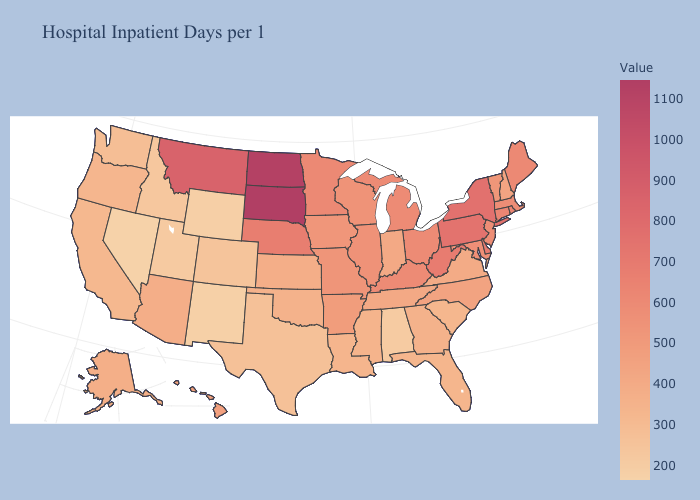Which states have the lowest value in the USA?
Be succinct. Nevada. Does Alabama have the highest value in the USA?
Quick response, please. No. Among the states that border North Dakota , which have the lowest value?
Give a very brief answer. Minnesota. Does Nevada have the lowest value in the USA?
Write a very short answer. Yes. Does the map have missing data?
Short answer required. No. Among the states that border California , which have the lowest value?
Write a very short answer. Nevada. Which states have the lowest value in the South?
Write a very short answer. Alabama. 